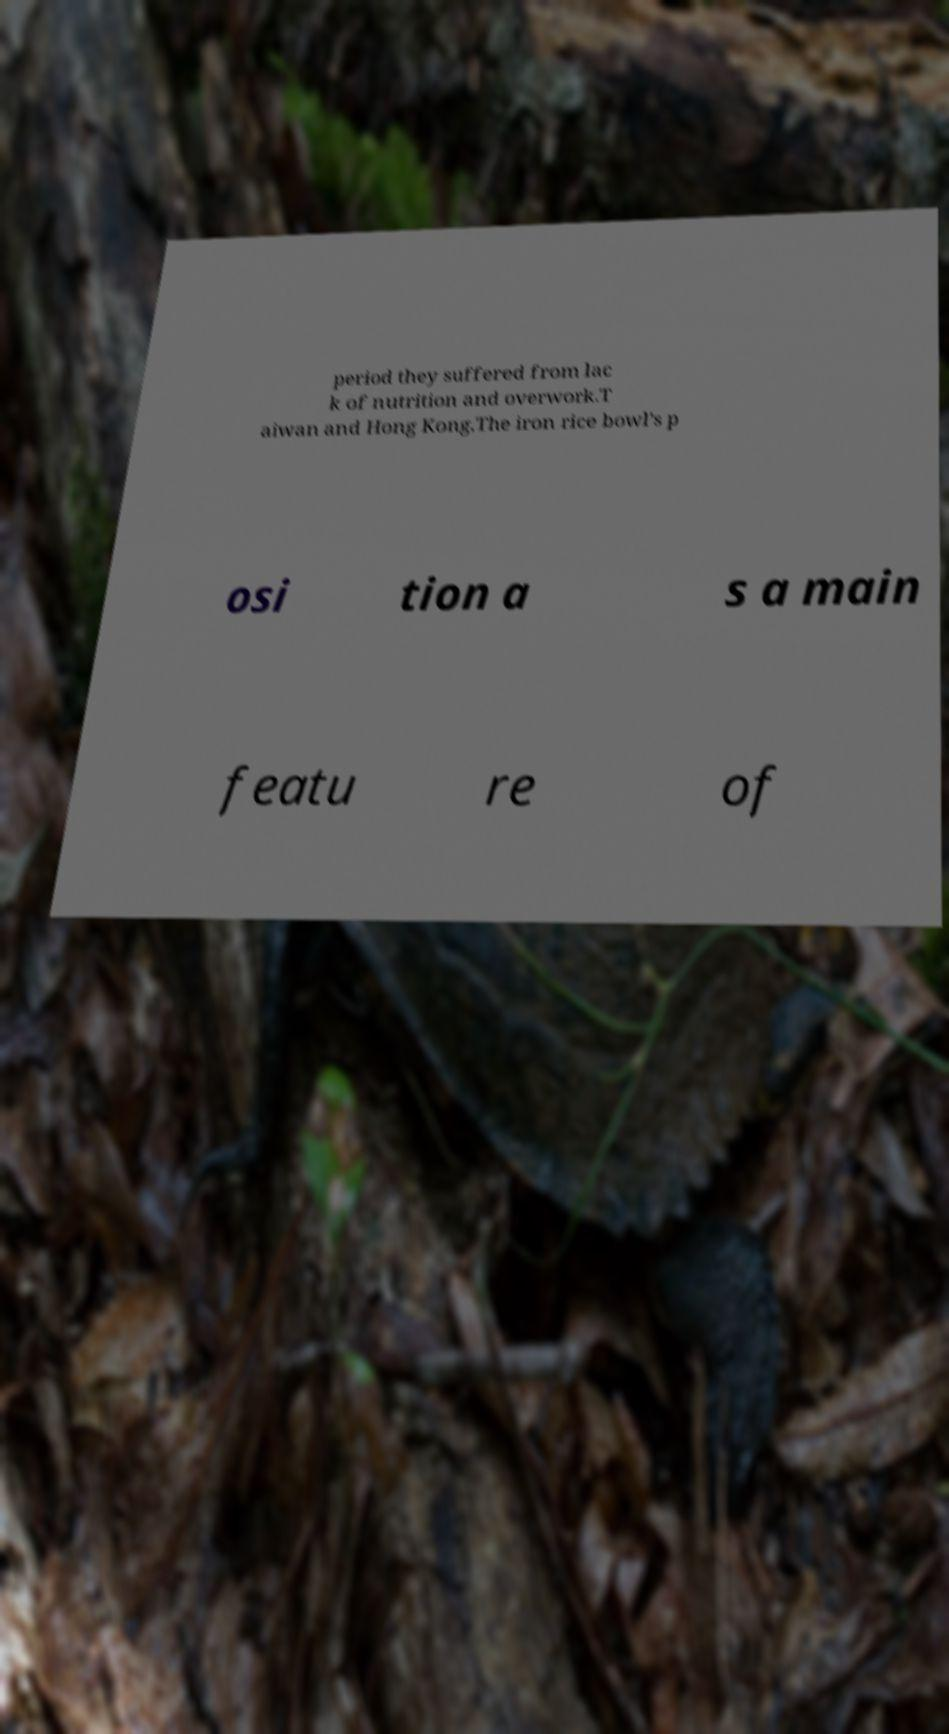Please read and relay the text visible in this image. What does it say? period they suffered from lac k of nutrition and overwork.T aiwan and Hong Kong.The iron rice bowl's p osi tion a s a main featu re of 